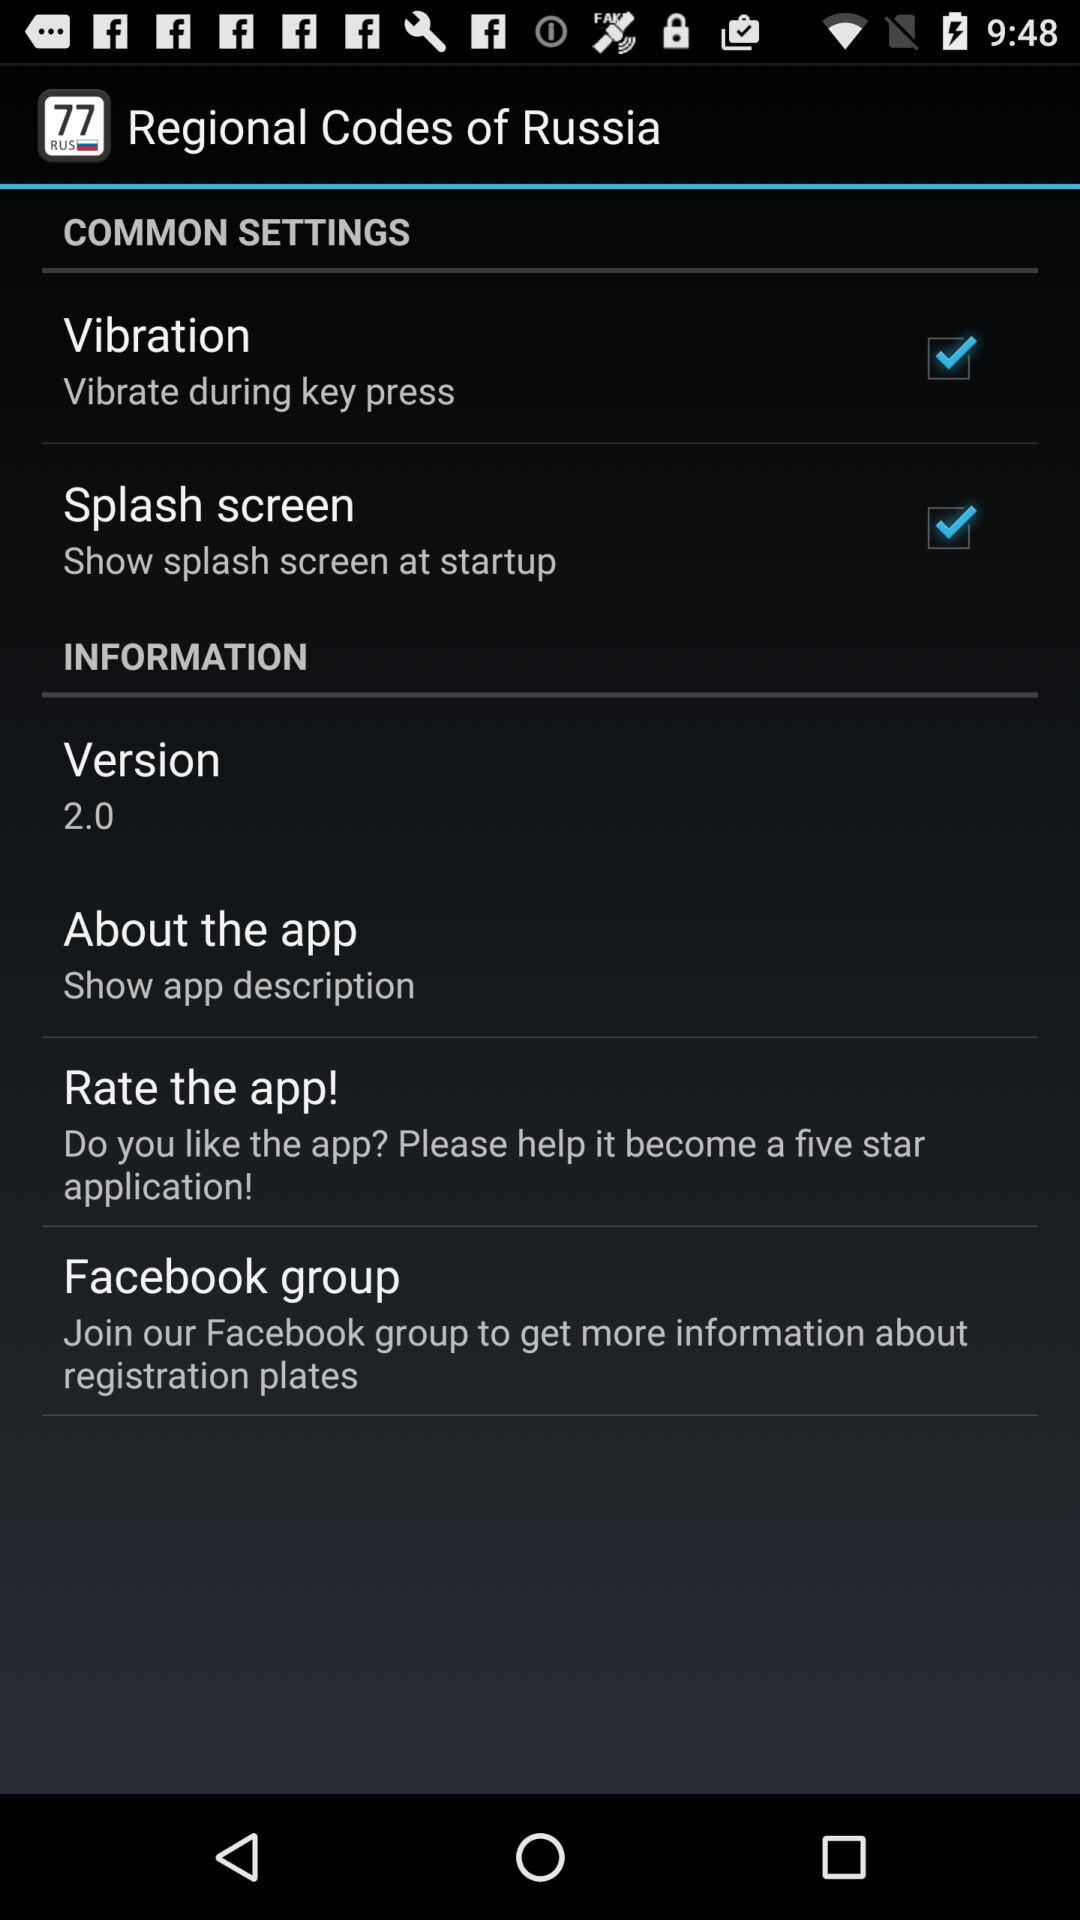What is the status of "Splash screen"? The status of "Splash screen" is "on". 